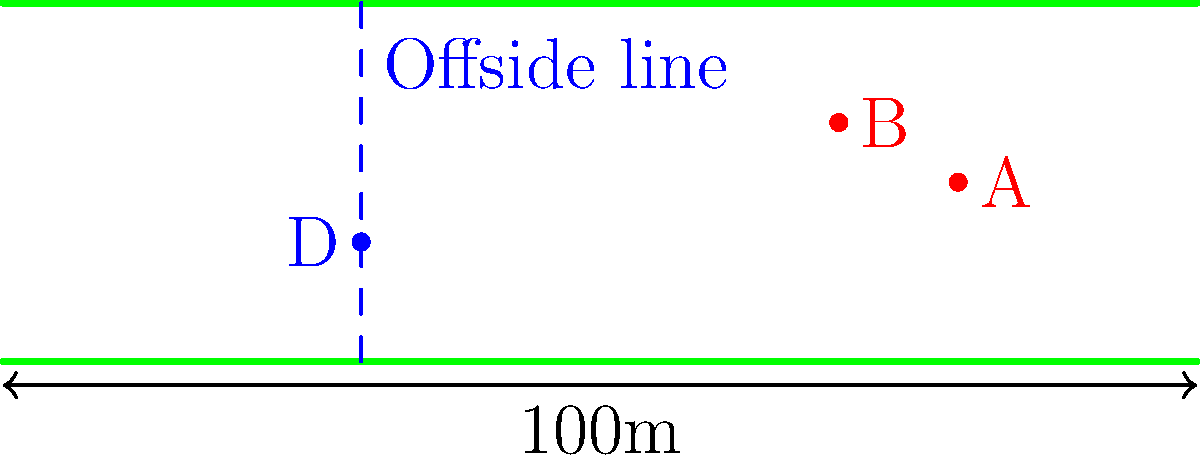In a crucial match, you're analyzing the offside position. The field is 100 meters long, and the defending player D is 30 meters from their own goal line. Attacking players A and B are positioned as shown. How far is the offside line from the goal line of the team being attacked? Let's approach this step-by-step:

1) First, we need to understand the offside rule. The offside line is determined by the position of the second-last defender (including the goalkeeper) from their own goal line.

2) In this case, player D is the second-last defender (assuming the goalkeeper is closer to the goal line).

3) We're told that the field is 100 meters long and player D is 30 meters from their own goal line.

4) To find the distance of the offside line from the goal line of the team being attacked, we need to subtract D's position from the total field length:

   $$\text{Offside line position} = \text{Field length} - \text{D's position from own goal}$$
   $$= 100 \text{ meters} - 30 \text{ meters}$$
   $$= 70 \text{ meters}$$

5) Therefore, the offside line is 70 meters from the goal line of the team being attacked.

6) We can verify that player A is in an offside position (beyond the offside line), while player B appears to be onside (behind the offside line).
Answer: 70 meters 